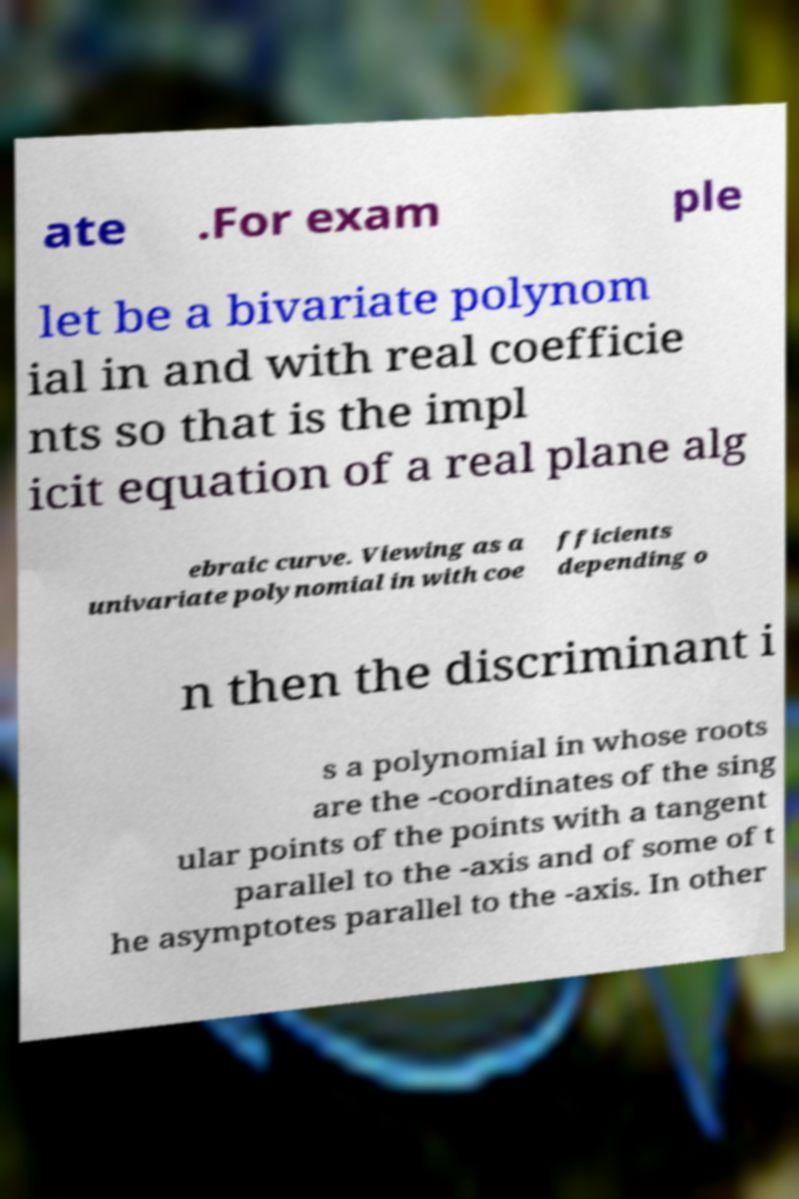There's text embedded in this image that I need extracted. Can you transcribe it verbatim? ate .For exam ple let be a bivariate polynom ial in and with real coefficie nts so that is the impl icit equation of a real plane alg ebraic curve. Viewing as a univariate polynomial in with coe fficients depending o n then the discriminant i s a polynomial in whose roots are the -coordinates of the sing ular points of the points with a tangent parallel to the -axis and of some of t he asymptotes parallel to the -axis. In other 